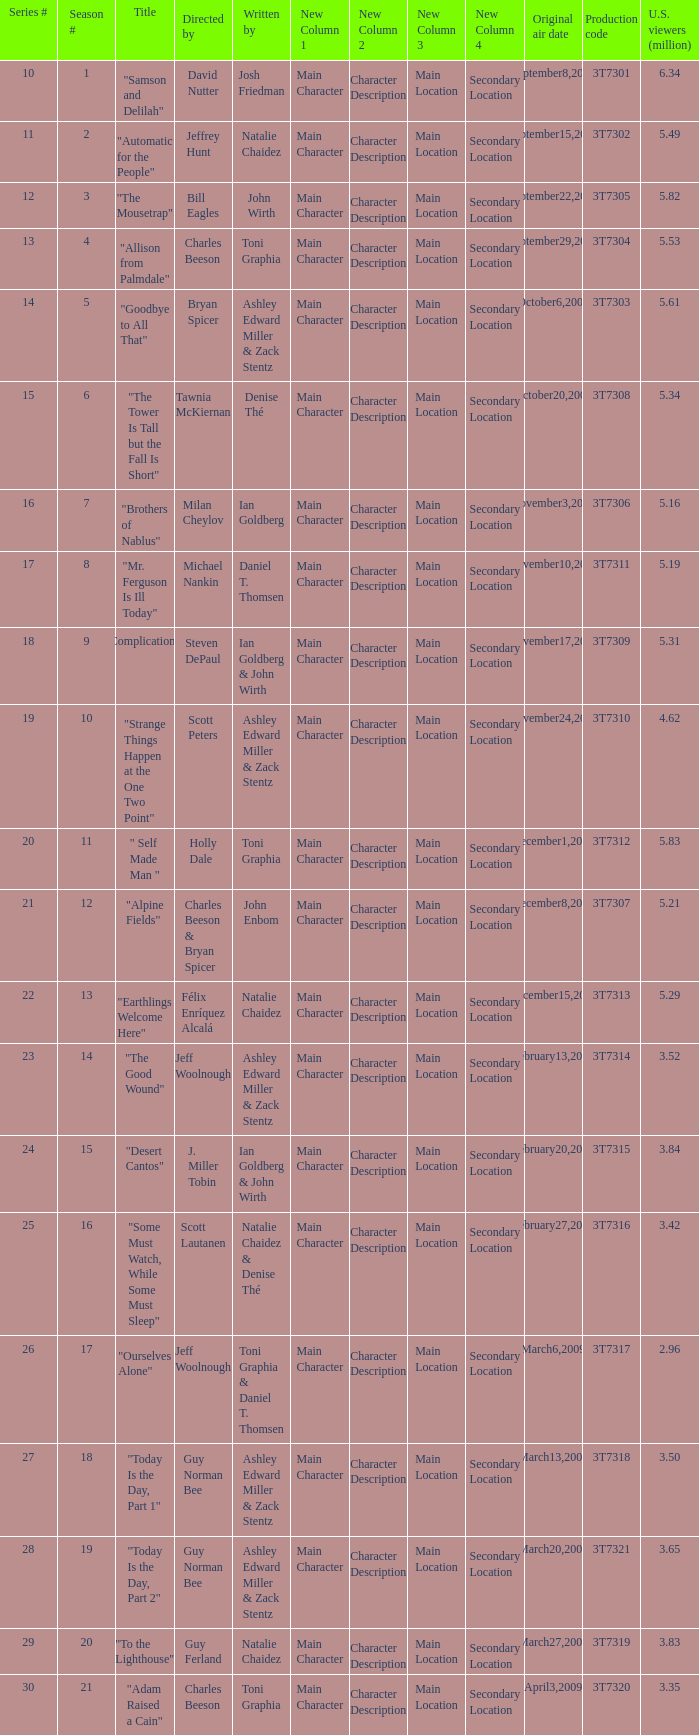Which episode number drew in 3.84 million viewers in the U.S.? 24.0. 